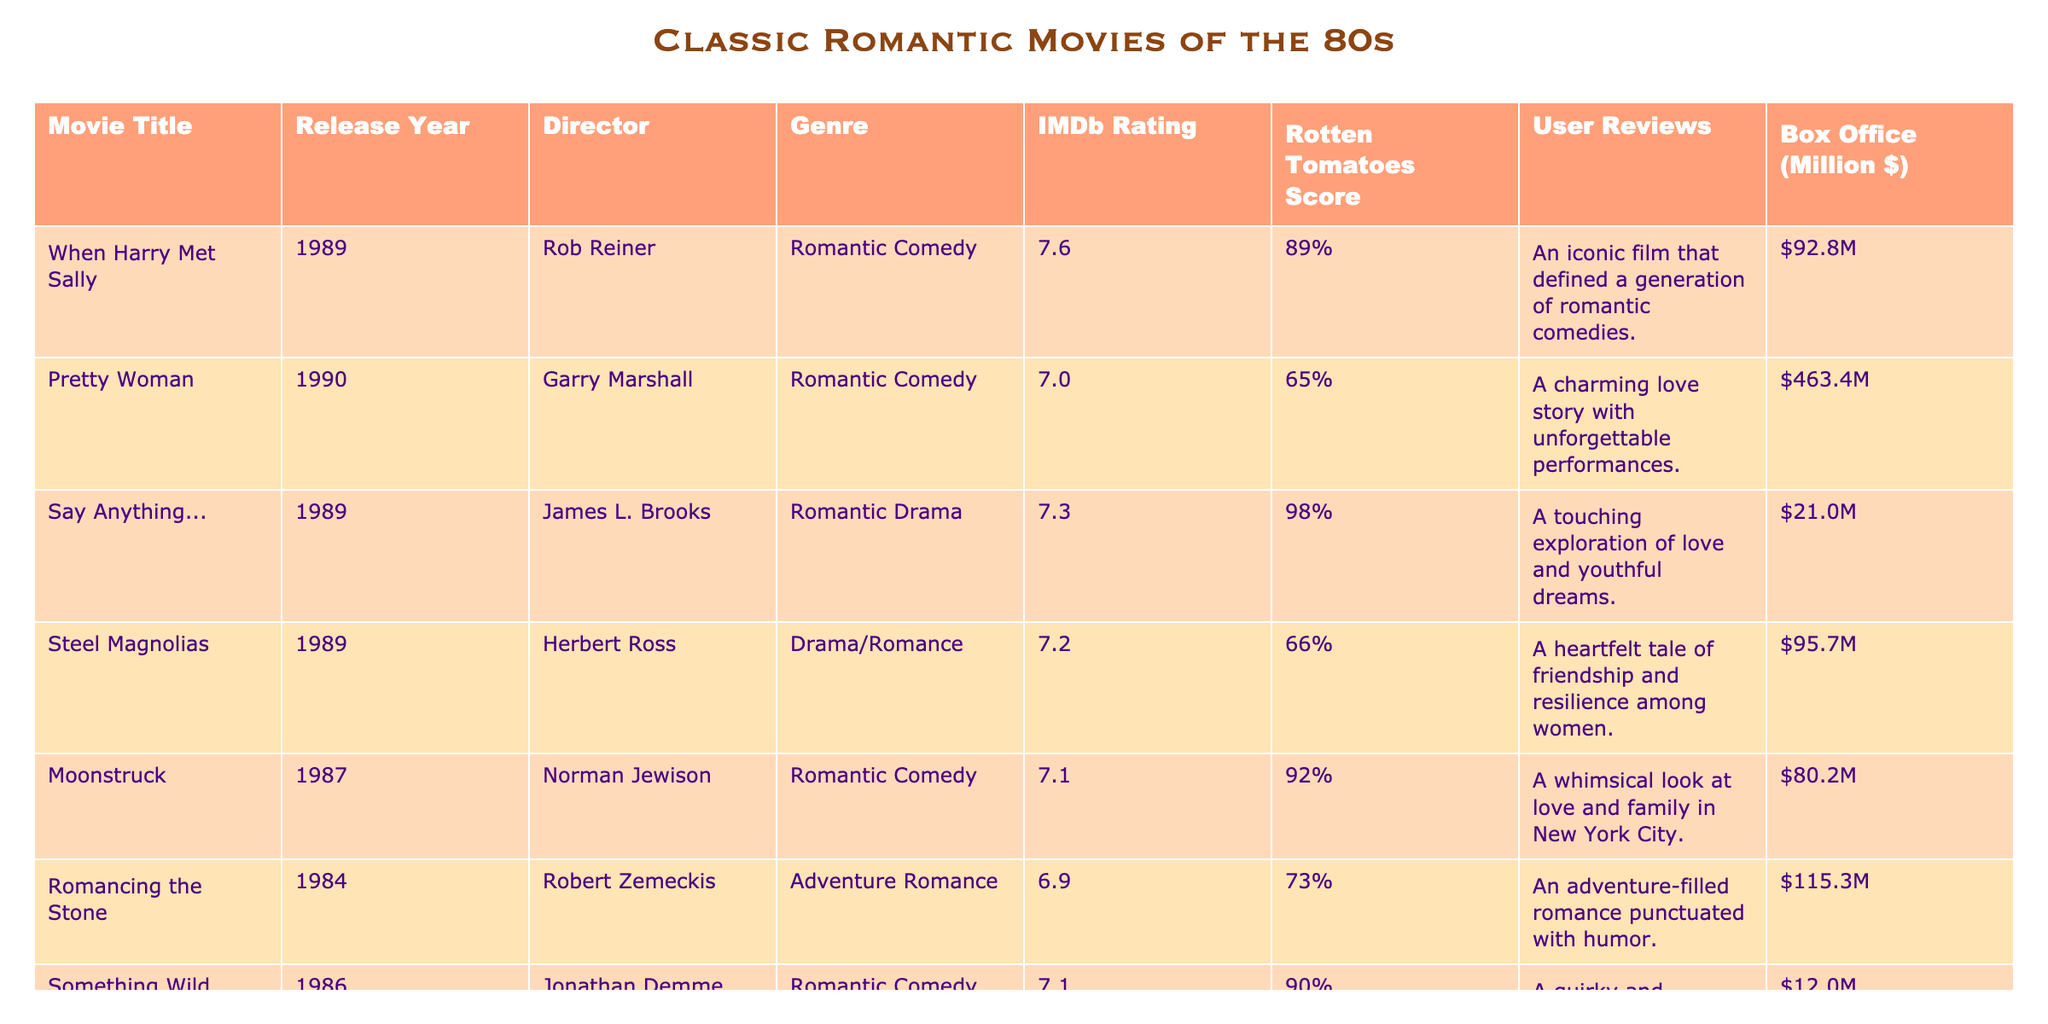What is the IMDb rating for "Pretty Woman"? According to the table, the IMDb rating column lists "Pretty Woman" with a rating of 7.0.
Answer: 7.0 Which movie has the highest Rotten Tomatoes score? By examining the Rotten Tomatoes score column, "Say Anything..." has the highest score of 98%.
Answer: "Say Anything..." What is the average box office gross of the movies listed? The box office values can be summed: 92.8 + 463.4 + 21.0 + 95.7 + 80.2 + 115.3 + 12.0 = 880.4 million dollars. There are 7 movies, so the average is 880.4 / 7 = 125.77 million dollars.
Answer: 125.77 million dollars Did "Steel Magnolias" have a higher IMDb rating than "Moonstruck"? The IMDb rating for "Steel Magnolias" is 7.2, and for "Moonstruck," it is 7.1. Since 7.2 is greater than 7.1, "Steel Magnolias" does have a higher rating.
Answer: Yes What is the difference in Box Office gross between "Pretty Woman" and "Say Anything..."? "Pretty Woman" made 463.4 million dollars and "Say Anything..." made 21.0 million dollars. The difference is 463.4 - 21.0 = 442.4 million dollars.
Answer: 442.4 million dollars Which movie is classified as both a romantic comedy and has the lowest box office gross? The table indicates "Something Wild" as a romantic comedy with a box office gross of 12.0 million dollars, the lowest among the movies.
Answer: "Something Wild" Count how many movies received a Rotten Tomatoes score of 90% or higher. The movies "Say Anything..." (98%), "Moonstruck" (92%), "Something Wild" (90%), and "When Harry Met Sally" (89%) have scores of 90% or higher. Four movies meet this criterion.
Answer: 3 movies What is the median IMDb rating of the movies listed? The IMDb ratings are: 7.0, 7.1, 7.1, 7.2, 7.3, 7.6 (sorted). There are 7 total ratings, and the median is the 4th value when sorted. Thus, the median IMDb rating is 7.2.
Answer: 7.2 Is the user review for "Moonstruck" positive? The user review for "Moonstruck" states it's a "whimsical look at love and family," which indicates a positive sentiment towards the film.
Answer: Yes What ratio of romantic comedies to romantic dramas is listed in the table? There are four romantic comedies ("When Harry Met Sally," "Pretty Woman," "Moonstruck," "Something Wild") and two romantic dramas ("Say Anything..." and "Steel Magnolias"). The ratio is 4:2, which simplifies to 2:1.
Answer: 2:1 Which director had the highest-rated movie in this list? "Say Anything..." directed by James L. Brooks has the highest IMDb rating of 7.3, making him the director of the highest-rated film.
Answer: James L. Brooks 